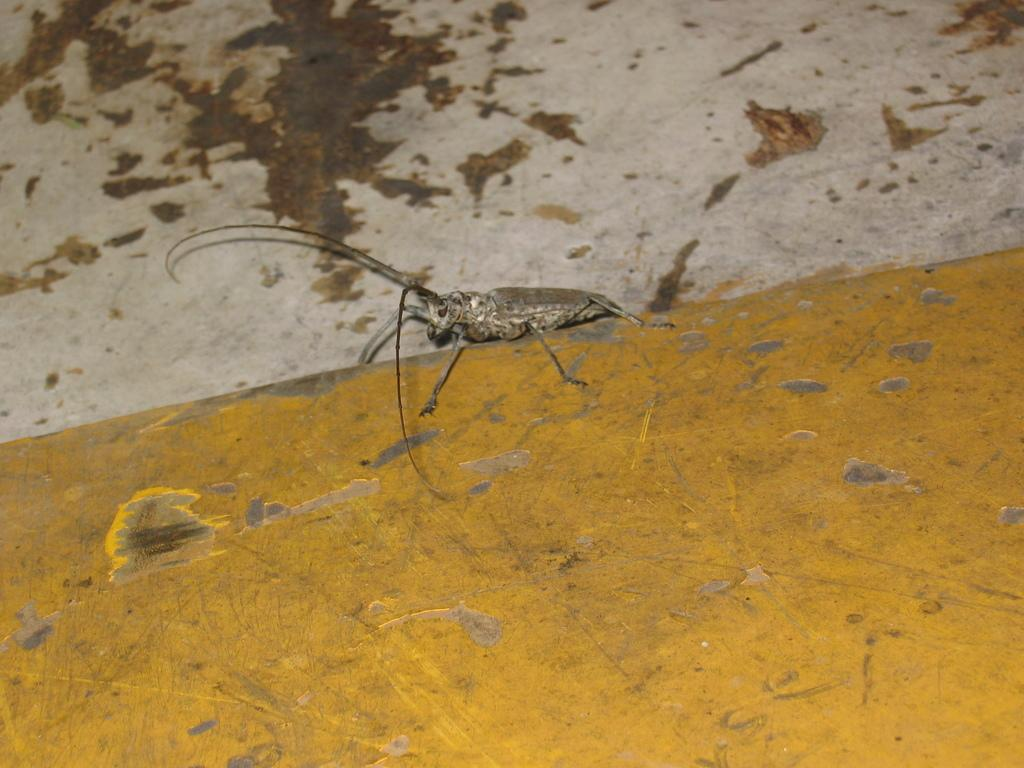What type of creature is present in the image? There is an insect in the image. Where is the insect located in the image? The insect is standing on a wall. What type of airport is visible in the image? There is no airport present in the image; it features an insect standing on a wall. What type of religious symbol can be seen in the image? There is no religious symbol present in the image; it features an insect standing on a wall. 